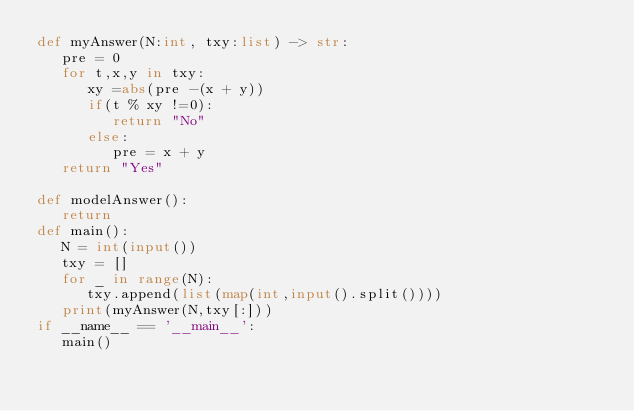Convert code to text. <code><loc_0><loc_0><loc_500><loc_500><_Python_>def myAnswer(N:int, txy:list) -> str:
   pre = 0
   for t,x,y in txy:
      xy =abs(pre -(x + y))
      if(t % xy !=0):
         return "No"
      else:
         pre = x + y
   return "Yes"

def modelAnswer():
   return
def main():
   N = int(input())
   txy = []
   for _ in range(N):
      txy.append(list(map(int,input().split())))
   print(myAnswer(N,txy[:]))
if __name__ == '__main__':
   main()</code> 